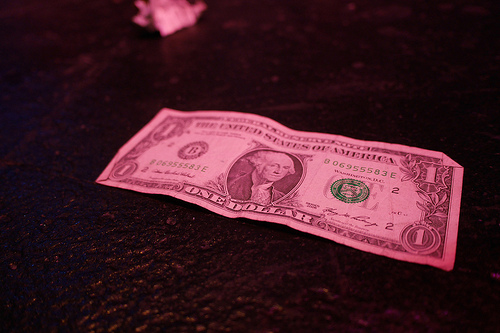<image>
Is the five dollars next to the ground? No. The five dollars is not positioned next to the ground. They are located in different areas of the scene. Where is the money in relation to the table? Is it in front of the table? No. The money is not in front of the table. The spatial positioning shows a different relationship between these objects. 